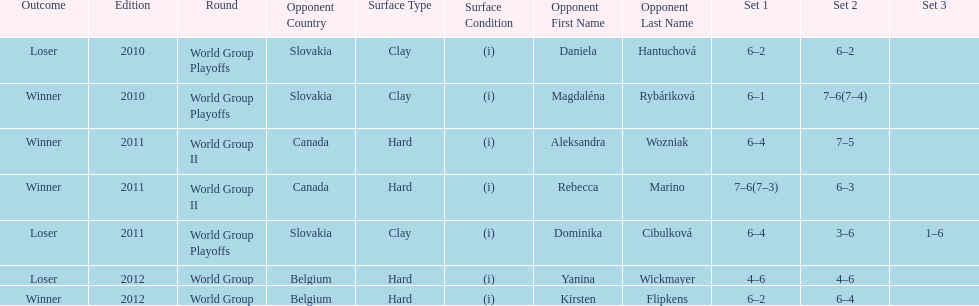What is the other year slovakia played besides 2010? 2011. 